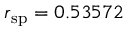<formula> <loc_0><loc_0><loc_500><loc_500>r _ { s p } = 0 . 5 3 5 7 2</formula> 